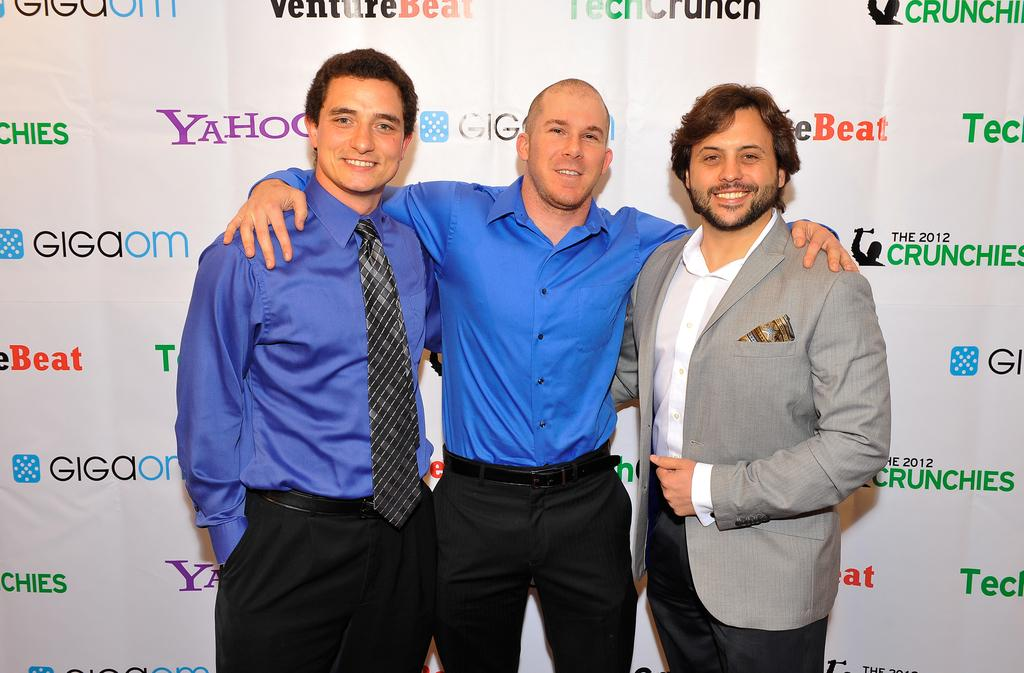How many people are in the image? There are three persons in the image. What are the persons doing in the image? The persons are standing. What are the persons wearing in the image? The persons are wearing clothes. What additional object can be seen in the image? There is a sponsorship cardboard banner in the image. What type of screw can be seen on the person's shirt in the image? There is no screw visible on any person's shirt in the image. Is there a locket hanging from the person's neck in the image? There is no locket visible on any person's neck in the image. 